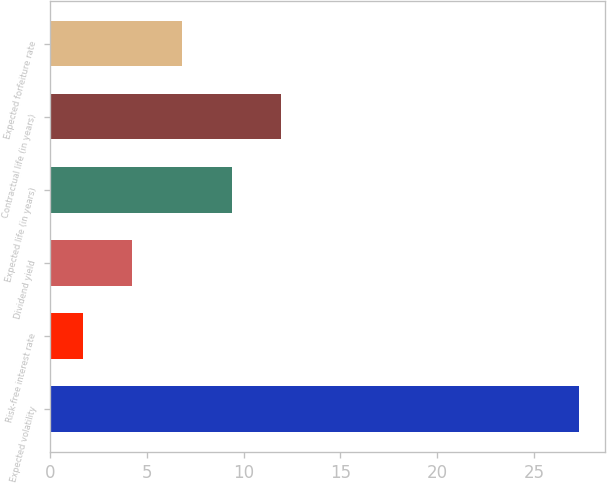Convert chart to OTSL. <chart><loc_0><loc_0><loc_500><loc_500><bar_chart><fcel>Expected volatility<fcel>Risk-free interest rate<fcel>Dividend yield<fcel>Expected life (in years)<fcel>Contractual life (in years)<fcel>Expected forfeiture rate<nl><fcel>27.3<fcel>1.7<fcel>4.26<fcel>9.38<fcel>11.94<fcel>6.82<nl></chart> 